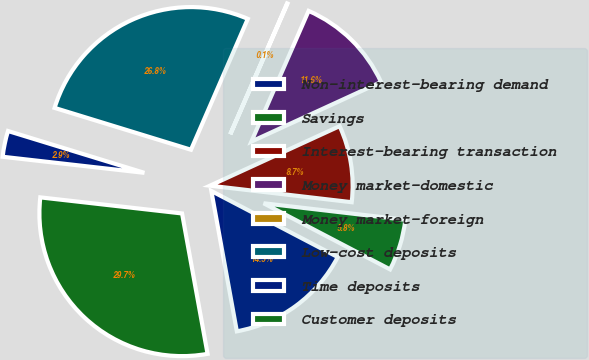Convert chart. <chart><loc_0><loc_0><loc_500><loc_500><pie_chart><fcel>Non-interest-bearing demand<fcel>Savings<fcel>Interest-bearing transaction<fcel>Money market-domestic<fcel>Money market-foreign<fcel>Low-cost deposits<fcel>Time deposits<fcel>Customer deposits<nl><fcel>14.47%<fcel>5.82%<fcel>8.7%<fcel>11.58%<fcel>0.05%<fcel>26.78%<fcel>2.94%<fcel>29.66%<nl></chart> 